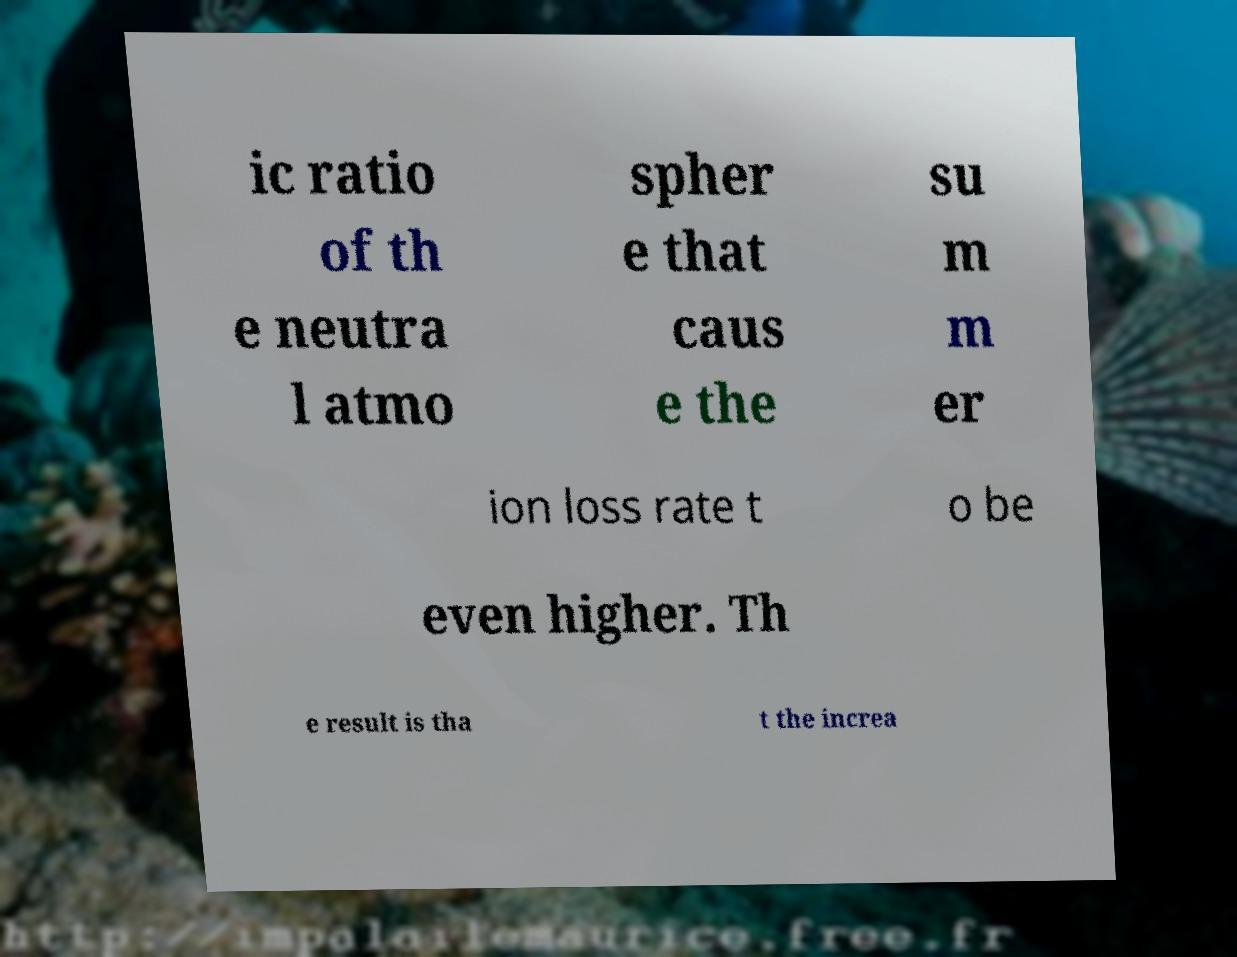For documentation purposes, I need the text within this image transcribed. Could you provide that? ic ratio of th e neutra l atmo spher e that caus e the su m m er ion loss rate t o be even higher. Th e result is tha t the increa 